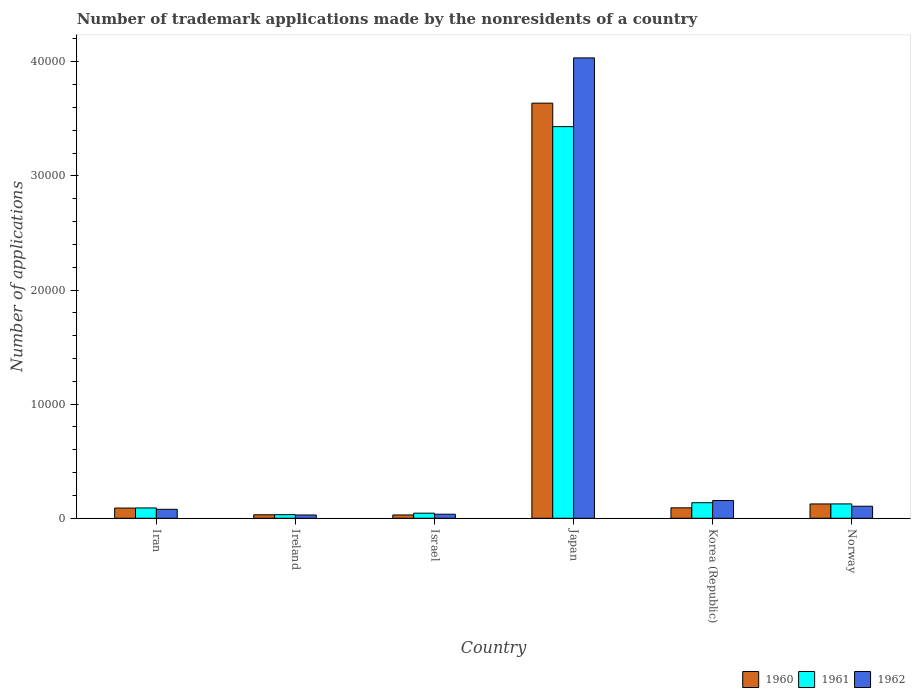How many different coloured bars are there?
Make the answer very short. 3. How many groups of bars are there?
Your answer should be compact. 6. How many bars are there on the 5th tick from the left?
Your answer should be compact. 3. What is the label of the 5th group of bars from the left?
Provide a short and direct response. Korea (Republic). In how many cases, is the number of bars for a given country not equal to the number of legend labels?
Provide a succinct answer. 0. What is the number of trademark applications made by the nonresidents in 1960 in Korea (Republic)?
Offer a very short reply. 916. Across all countries, what is the maximum number of trademark applications made by the nonresidents in 1961?
Ensure brevity in your answer.  3.43e+04. Across all countries, what is the minimum number of trademark applications made by the nonresidents in 1962?
Provide a succinct answer. 288. In which country was the number of trademark applications made by the nonresidents in 1962 minimum?
Keep it short and to the point. Ireland. What is the total number of trademark applications made by the nonresidents in 1962 in the graph?
Offer a very short reply. 4.44e+04. What is the difference between the number of trademark applications made by the nonresidents in 1962 in Japan and that in Norway?
Ensure brevity in your answer.  3.93e+04. What is the difference between the number of trademark applications made by the nonresidents in 1961 in Ireland and the number of trademark applications made by the nonresidents in 1962 in Japan?
Offer a very short reply. -4.00e+04. What is the average number of trademark applications made by the nonresidents in 1962 per country?
Keep it short and to the point. 7396.83. What is the difference between the number of trademark applications made by the nonresidents of/in 1962 and number of trademark applications made by the nonresidents of/in 1961 in Norway?
Your answer should be compact. -203. In how many countries, is the number of trademark applications made by the nonresidents in 1961 greater than 30000?
Offer a very short reply. 1. What is the ratio of the number of trademark applications made by the nonresidents in 1961 in Israel to that in Norway?
Make the answer very short. 0.35. Is the number of trademark applications made by the nonresidents in 1962 in Ireland less than that in Japan?
Your answer should be very brief. Yes. What is the difference between the highest and the second highest number of trademark applications made by the nonresidents in 1962?
Make the answer very short. 499. What is the difference between the highest and the lowest number of trademark applications made by the nonresidents in 1960?
Your answer should be very brief. 3.61e+04. Is the sum of the number of trademark applications made by the nonresidents in 1960 in Japan and Norway greater than the maximum number of trademark applications made by the nonresidents in 1961 across all countries?
Your answer should be compact. Yes. What does the 2nd bar from the right in Israel represents?
Give a very brief answer. 1961. How many bars are there?
Your answer should be very brief. 18. Are all the bars in the graph horizontal?
Offer a terse response. No. How many countries are there in the graph?
Provide a succinct answer. 6. What is the difference between two consecutive major ticks on the Y-axis?
Your answer should be compact. 10000. Are the values on the major ticks of Y-axis written in scientific E-notation?
Offer a terse response. No. Does the graph contain grids?
Offer a very short reply. No. How are the legend labels stacked?
Ensure brevity in your answer.  Horizontal. What is the title of the graph?
Your answer should be compact. Number of trademark applications made by the nonresidents of a country. Does "2009" appear as one of the legend labels in the graph?
Offer a very short reply. No. What is the label or title of the X-axis?
Offer a very short reply. Country. What is the label or title of the Y-axis?
Provide a short and direct response. Number of applications. What is the Number of applications of 1960 in Iran?
Make the answer very short. 895. What is the Number of applications of 1961 in Iran?
Your answer should be compact. 905. What is the Number of applications in 1962 in Iran?
Your answer should be very brief. 786. What is the Number of applications of 1960 in Ireland?
Give a very brief answer. 305. What is the Number of applications in 1961 in Ireland?
Offer a very short reply. 316. What is the Number of applications of 1962 in Ireland?
Your response must be concise. 288. What is the Number of applications of 1960 in Israel?
Ensure brevity in your answer.  290. What is the Number of applications of 1961 in Israel?
Ensure brevity in your answer.  446. What is the Number of applications of 1962 in Israel?
Make the answer very short. 355. What is the Number of applications of 1960 in Japan?
Offer a very short reply. 3.64e+04. What is the Number of applications in 1961 in Japan?
Your response must be concise. 3.43e+04. What is the Number of applications of 1962 in Japan?
Keep it short and to the point. 4.03e+04. What is the Number of applications of 1960 in Korea (Republic)?
Your answer should be compact. 916. What is the Number of applications of 1961 in Korea (Republic)?
Offer a very short reply. 1363. What is the Number of applications in 1962 in Korea (Republic)?
Offer a terse response. 1554. What is the Number of applications of 1960 in Norway?
Offer a very short reply. 1255. What is the Number of applications of 1961 in Norway?
Offer a terse response. 1258. What is the Number of applications in 1962 in Norway?
Your answer should be compact. 1055. Across all countries, what is the maximum Number of applications of 1960?
Your answer should be very brief. 3.64e+04. Across all countries, what is the maximum Number of applications of 1961?
Offer a terse response. 3.43e+04. Across all countries, what is the maximum Number of applications of 1962?
Provide a succinct answer. 4.03e+04. Across all countries, what is the minimum Number of applications in 1960?
Offer a terse response. 290. Across all countries, what is the minimum Number of applications in 1961?
Keep it short and to the point. 316. Across all countries, what is the minimum Number of applications of 1962?
Provide a short and direct response. 288. What is the total Number of applications in 1960 in the graph?
Provide a succinct answer. 4.00e+04. What is the total Number of applications in 1961 in the graph?
Your answer should be compact. 3.86e+04. What is the total Number of applications of 1962 in the graph?
Ensure brevity in your answer.  4.44e+04. What is the difference between the Number of applications of 1960 in Iran and that in Ireland?
Offer a very short reply. 590. What is the difference between the Number of applications of 1961 in Iran and that in Ireland?
Give a very brief answer. 589. What is the difference between the Number of applications in 1962 in Iran and that in Ireland?
Make the answer very short. 498. What is the difference between the Number of applications of 1960 in Iran and that in Israel?
Ensure brevity in your answer.  605. What is the difference between the Number of applications of 1961 in Iran and that in Israel?
Provide a succinct answer. 459. What is the difference between the Number of applications in 1962 in Iran and that in Israel?
Your response must be concise. 431. What is the difference between the Number of applications in 1960 in Iran and that in Japan?
Offer a very short reply. -3.55e+04. What is the difference between the Number of applications of 1961 in Iran and that in Japan?
Offer a very short reply. -3.34e+04. What is the difference between the Number of applications in 1962 in Iran and that in Japan?
Your answer should be compact. -3.96e+04. What is the difference between the Number of applications in 1960 in Iran and that in Korea (Republic)?
Your response must be concise. -21. What is the difference between the Number of applications of 1961 in Iran and that in Korea (Republic)?
Provide a short and direct response. -458. What is the difference between the Number of applications in 1962 in Iran and that in Korea (Republic)?
Provide a succinct answer. -768. What is the difference between the Number of applications in 1960 in Iran and that in Norway?
Provide a succinct answer. -360. What is the difference between the Number of applications in 1961 in Iran and that in Norway?
Your answer should be compact. -353. What is the difference between the Number of applications of 1962 in Iran and that in Norway?
Your answer should be very brief. -269. What is the difference between the Number of applications of 1960 in Ireland and that in Israel?
Keep it short and to the point. 15. What is the difference between the Number of applications of 1961 in Ireland and that in Israel?
Your response must be concise. -130. What is the difference between the Number of applications in 1962 in Ireland and that in Israel?
Offer a terse response. -67. What is the difference between the Number of applications in 1960 in Ireland and that in Japan?
Give a very brief answer. -3.61e+04. What is the difference between the Number of applications in 1961 in Ireland and that in Japan?
Your answer should be very brief. -3.40e+04. What is the difference between the Number of applications of 1962 in Ireland and that in Japan?
Offer a very short reply. -4.01e+04. What is the difference between the Number of applications in 1960 in Ireland and that in Korea (Republic)?
Your answer should be very brief. -611. What is the difference between the Number of applications in 1961 in Ireland and that in Korea (Republic)?
Offer a very short reply. -1047. What is the difference between the Number of applications of 1962 in Ireland and that in Korea (Republic)?
Make the answer very short. -1266. What is the difference between the Number of applications in 1960 in Ireland and that in Norway?
Your answer should be very brief. -950. What is the difference between the Number of applications of 1961 in Ireland and that in Norway?
Keep it short and to the point. -942. What is the difference between the Number of applications in 1962 in Ireland and that in Norway?
Your response must be concise. -767. What is the difference between the Number of applications in 1960 in Israel and that in Japan?
Your answer should be compact. -3.61e+04. What is the difference between the Number of applications in 1961 in Israel and that in Japan?
Give a very brief answer. -3.39e+04. What is the difference between the Number of applications in 1962 in Israel and that in Japan?
Keep it short and to the point. -4.00e+04. What is the difference between the Number of applications of 1960 in Israel and that in Korea (Republic)?
Keep it short and to the point. -626. What is the difference between the Number of applications of 1961 in Israel and that in Korea (Republic)?
Your answer should be compact. -917. What is the difference between the Number of applications of 1962 in Israel and that in Korea (Republic)?
Your answer should be compact. -1199. What is the difference between the Number of applications of 1960 in Israel and that in Norway?
Give a very brief answer. -965. What is the difference between the Number of applications of 1961 in Israel and that in Norway?
Make the answer very short. -812. What is the difference between the Number of applications in 1962 in Israel and that in Norway?
Make the answer very short. -700. What is the difference between the Number of applications in 1960 in Japan and that in Korea (Republic)?
Give a very brief answer. 3.55e+04. What is the difference between the Number of applications in 1961 in Japan and that in Korea (Republic)?
Provide a short and direct response. 3.30e+04. What is the difference between the Number of applications of 1962 in Japan and that in Korea (Republic)?
Offer a very short reply. 3.88e+04. What is the difference between the Number of applications of 1960 in Japan and that in Norway?
Provide a succinct answer. 3.51e+04. What is the difference between the Number of applications of 1961 in Japan and that in Norway?
Provide a succinct answer. 3.31e+04. What is the difference between the Number of applications of 1962 in Japan and that in Norway?
Give a very brief answer. 3.93e+04. What is the difference between the Number of applications in 1960 in Korea (Republic) and that in Norway?
Your answer should be very brief. -339. What is the difference between the Number of applications of 1961 in Korea (Republic) and that in Norway?
Make the answer very short. 105. What is the difference between the Number of applications of 1962 in Korea (Republic) and that in Norway?
Ensure brevity in your answer.  499. What is the difference between the Number of applications in 1960 in Iran and the Number of applications in 1961 in Ireland?
Provide a succinct answer. 579. What is the difference between the Number of applications of 1960 in Iran and the Number of applications of 1962 in Ireland?
Your response must be concise. 607. What is the difference between the Number of applications in 1961 in Iran and the Number of applications in 1962 in Ireland?
Give a very brief answer. 617. What is the difference between the Number of applications of 1960 in Iran and the Number of applications of 1961 in Israel?
Make the answer very short. 449. What is the difference between the Number of applications of 1960 in Iran and the Number of applications of 1962 in Israel?
Ensure brevity in your answer.  540. What is the difference between the Number of applications in 1961 in Iran and the Number of applications in 1962 in Israel?
Your answer should be very brief. 550. What is the difference between the Number of applications in 1960 in Iran and the Number of applications in 1961 in Japan?
Offer a terse response. -3.34e+04. What is the difference between the Number of applications in 1960 in Iran and the Number of applications in 1962 in Japan?
Your response must be concise. -3.94e+04. What is the difference between the Number of applications of 1961 in Iran and the Number of applications of 1962 in Japan?
Ensure brevity in your answer.  -3.94e+04. What is the difference between the Number of applications of 1960 in Iran and the Number of applications of 1961 in Korea (Republic)?
Make the answer very short. -468. What is the difference between the Number of applications of 1960 in Iran and the Number of applications of 1962 in Korea (Republic)?
Your answer should be very brief. -659. What is the difference between the Number of applications in 1961 in Iran and the Number of applications in 1962 in Korea (Republic)?
Ensure brevity in your answer.  -649. What is the difference between the Number of applications of 1960 in Iran and the Number of applications of 1961 in Norway?
Your response must be concise. -363. What is the difference between the Number of applications of 1960 in Iran and the Number of applications of 1962 in Norway?
Your answer should be very brief. -160. What is the difference between the Number of applications in 1961 in Iran and the Number of applications in 1962 in Norway?
Offer a very short reply. -150. What is the difference between the Number of applications in 1960 in Ireland and the Number of applications in 1961 in Israel?
Ensure brevity in your answer.  -141. What is the difference between the Number of applications of 1960 in Ireland and the Number of applications of 1962 in Israel?
Make the answer very short. -50. What is the difference between the Number of applications of 1961 in Ireland and the Number of applications of 1962 in Israel?
Your response must be concise. -39. What is the difference between the Number of applications in 1960 in Ireland and the Number of applications in 1961 in Japan?
Your answer should be compact. -3.40e+04. What is the difference between the Number of applications of 1960 in Ireland and the Number of applications of 1962 in Japan?
Your answer should be compact. -4.00e+04. What is the difference between the Number of applications of 1961 in Ireland and the Number of applications of 1962 in Japan?
Your answer should be compact. -4.00e+04. What is the difference between the Number of applications of 1960 in Ireland and the Number of applications of 1961 in Korea (Republic)?
Provide a succinct answer. -1058. What is the difference between the Number of applications in 1960 in Ireland and the Number of applications in 1962 in Korea (Republic)?
Your response must be concise. -1249. What is the difference between the Number of applications in 1961 in Ireland and the Number of applications in 1962 in Korea (Republic)?
Make the answer very short. -1238. What is the difference between the Number of applications in 1960 in Ireland and the Number of applications in 1961 in Norway?
Provide a short and direct response. -953. What is the difference between the Number of applications of 1960 in Ireland and the Number of applications of 1962 in Norway?
Make the answer very short. -750. What is the difference between the Number of applications in 1961 in Ireland and the Number of applications in 1962 in Norway?
Keep it short and to the point. -739. What is the difference between the Number of applications of 1960 in Israel and the Number of applications of 1961 in Japan?
Your answer should be very brief. -3.40e+04. What is the difference between the Number of applications in 1960 in Israel and the Number of applications in 1962 in Japan?
Keep it short and to the point. -4.01e+04. What is the difference between the Number of applications of 1961 in Israel and the Number of applications of 1962 in Japan?
Offer a very short reply. -3.99e+04. What is the difference between the Number of applications of 1960 in Israel and the Number of applications of 1961 in Korea (Republic)?
Make the answer very short. -1073. What is the difference between the Number of applications in 1960 in Israel and the Number of applications in 1962 in Korea (Republic)?
Keep it short and to the point. -1264. What is the difference between the Number of applications in 1961 in Israel and the Number of applications in 1962 in Korea (Republic)?
Your answer should be very brief. -1108. What is the difference between the Number of applications in 1960 in Israel and the Number of applications in 1961 in Norway?
Ensure brevity in your answer.  -968. What is the difference between the Number of applications in 1960 in Israel and the Number of applications in 1962 in Norway?
Your answer should be very brief. -765. What is the difference between the Number of applications in 1961 in Israel and the Number of applications in 1962 in Norway?
Keep it short and to the point. -609. What is the difference between the Number of applications of 1960 in Japan and the Number of applications of 1961 in Korea (Republic)?
Provide a succinct answer. 3.50e+04. What is the difference between the Number of applications of 1960 in Japan and the Number of applications of 1962 in Korea (Republic)?
Provide a short and direct response. 3.48e+04. What is the difference between the Number of applications in 1961 in Japan and the Number of applications in 1962 in Korea (Republic)?
Provide a short and direct response. 3.28e+04. What is the difference between the Number of applications of 1960 in Japan and the Number of applications of 1961 in Norway?
Make the answer very short. 3.51e+04. What is the difference between the Number of applications of 1960 in Japan and the Number of applications of 1962 in Norway?
Make the answer very short. 3.53e+04. What is the difference between the Number of applications of 1961 in Japan and the Number of applications of 1962 in Norway?
Keep it short and to the point. 3.33e+04. What is the difference between the Number of applications of 1960 in Korea (Republic) and the Number of applications of 1961 in Norway?
Offer a terse response. -342. What is the difference between the Number of applications in 1960 in Korea (Republic) and the Number of applications in 1962 in Norway?
Offer a very short reply. -139. What is the difference between the Number of applications of 1961 in Korea (Republic) and the Number of applications of 1962 in Norway?
Give a very brief answer. 308. What is the average Number of applications in 1960 per country?
Give a very brief answer. 6673. What is the average Number of applications of 1961 per country?
Offer a very short reply. 6434.67. What is the average Number of applications of 1962 per country?
Provide a short and direct response. 7396.83. What is the difference between the Number of applications of 1960 and Number of applications of 1961 in Iran?
Your answer should be very brief. -10. What is the difference between the Number of applications in 1960 and Number of applications in 1962 in Iran?
Keep it short and to the point. 109. What is the difference between the Number of applications of 1961 and Number of applications of 1962 in Iran?
Your answer should be compact. 119. What is the difference between the Number of applications of 1960 and Number of applications of 1961 in Ireland?
Your response must be concise. -11. What is the difference between the Number of applications in 1960 and Number of applications in 1962 in Ireland?
Ensure brevity in your answer.  17. What is the difference between the Number of applications of 1961 and Number of applications of 1962 in Ireland?
Your answer should be very brief. 28. What is the difference between the Number of applications of 1960 and Number of applications of 1961 in Israel?
Provide a short and direct response. -156. What is the difference between the Number of applications of 1960 and Number of applications of 1962 in Israel?
Make the answer very short. -65. What is the difference between the Number of applications of 1961 and Number of applications of 1962 in Israel?
Give a very brief answer. 91. What is the difference between the Number of applications of 1960 and Number of applications of 1961 in Japan?
Ensure brevity in your answer.  2057. What is the difference between the Number of applications of 1960 and Number of applications of 1962 in Japan?
Ensure brevity in your answer.  -3966. What is the difference between the Number of applications of 1961 and Number of applications of 1962 in Japan?
Ensure brevity in your answer.  -6023. What is the difference between the Number of applications of 1960 and Number of applications of 1961 in Korea (Republic)?
Provide a short and direct response. -447. What is the difference between the Number of applications of 1960 and Number of applications of 1962 in Korea (Republic)?
Give a very brief answer. -638. What is the difference between the Number of applications of 1961 and Number of applications of 1962 in Korea (Republic)?
Your answer should be very brief. -191. What is the difference between the Number of applications in 1960 and Number of applications in 1961 in Norway?
Your response must be concise. -3. What is the difference between the Number of applications of 1961 and Number of applications of 1962 in Norway?
Your answer should be very brief. 203. What is the ratio of the Number of applications of 1960 in Iran to that in Ireland?
Make the answer very short. 2.93. What is the ratio of the Number of applications of 1961 in Iran to that in Ireland?
Keep it short and to the point. 2.86. What is the ratio of the Number of applications in 1962 in Iran to that in Ireland?
Give a very brief answer. 2.73. What is the ratio of the Number of applications of 1960 in Iran to that in Israel?
Your answer should be compact. 3.09. What is the ratio of the Number of applications of 1961 in Iran to that in Israel?
Offer a very short reply. 2.03. What is the ratio of the Number of applications of 1962 in Iran to that in Israel?
Offer a terse response. 2.21. What is the ratio of the Number of applications of 1960 in Iran to that in Japan?
Ensure brevity in your answer.  0.02. What is the ratio of the Number of applications of 1961 in Iran to that in Japan?
Your answer should be compact. 0.03. What is the ratio of the Number of applications of 1962 in Iran to that in Japan?
Provide a succinct answer. 0.02. What is the ratio of the Number of applications of 1960 in Iran to that in Korea (Republic)?
Your answer should be very brief. 0.98. What is the ratio of the Number of applications of 1961 in Iran to that in Korea (Republic)?
Provide a succinct answer. 0.66. What is the ratio of the Number of applications of 1962 in Iran to that in Korea (Republic)?
Your response must be concise. 0.51. What is the ratio of the Number of applications in 1960 in Iran to that in Norway?
Your answer should be compact. 0.71. What is the ratio of the Number of applications of 1961 in Iran to that in Norway?
Make the answer very short. 0.72. What is the ratio of the Number of applications in 1962 in Iran to that in Norway?
Offer a very short reply. 0.74. What is the ratio of the Number of applications in 1960 in Ireland to that in Israel?
Your answer should be very brief. 1.05. What is the ratio of the Number of applications in 1961 in Ireland to that in Israel?
Offer a very short reply. 0.71. What is the ratio of the Number of applications of 1962 in Ireland to that in Israel?
Your answer should be compact. 0.81. What is the ratio of the Number of applications of 1960 in Ireland to that in Japan?
Offer a terse response. 0.01. What is the ratio of the Number of applications of 1961 in Ireland to that in Japan?
Keep it short and to the point. 0.01. What is the ratio of the Number of applications of 1962 in Ireland to that in Japan?
Provide a short and direct response. 0.01. What is the ratio of the Number of applications in 1960 in Ireland to that in Korea (Republic)?
Offer a terse response. 0.33. What is the ratio of the Number of applications of 1961 in Ireland to that in Korea (Republic)?
Your answer should be compact. 0.23. What is the ratio of the Number of applications of 1962 in Ireland to that in Korea (Republic)?
Give a very brief answer. 0.19. What is the ratio of the Number of applications in 1960 in Ireland to that in Norway?
Your answer should be very brief. 0.24. What is the ratio of the Number of applications in 1961 in Ireland to that in Norway?
Provide a short and direct response. 0.25. What is the ratio of the Number of applications in 1962 in Ireland to that in Norway?
Provide a short and direct response. 0.27. What is the ratio of the Number of applications of 1960 in Israel to that in Japan?
Offer a very short reply. 0.01. What is the ratio of the Number of applications in 1961 in Israel to that in Japan?
Your response must be concise. 0.01. What is the ratio of the Number of applications of 1962 in Israel to that in Japan?
Offer a terse response. 0.01. What is the ratio of the Number of applications of 1960 in Israel to that in Korea (Republic)?
Your answer should be very brief. 0.32. What is the ratio of the Number of applications in 1961 in Israel to that in Korea (Republic)?
Offer a very short reply. 0.33. What is the ratio of the Number of applications in 1962 in Israel to that in Korea (Republic)?
Your answer should be compact. 0.23. What is the ratio of the Number of applications in 1960 in Israel to that in Norway?
Keep it short and to the point. 0.23. What is the ratio of the Number of applications of 1961 in Israel to that in Norway?
Your response must be concise. 0.35. What is the ratio of the Number of applications in 1962 in Israel to that in Norway?
Your answer should be very brief. 0.34. What is the ratio of the Number of applications in 1960 in Japan to that in Korea (Republic)?
Offer a very short reply. 39.71. What is the ratio of the Number of applications of 1961 in Japan to that in Korea (Republic)?
Give a very brief answer. 25.18. What is the ratio of the Number of applications in 1962 in Japan to that in Korea (Republic)?
Provide a short and direct response. 25.96. What is the ratio of the Number of applications in 1960 in Japan to that in Norway?
Your response must be concise. 28.99. What is the ratio of the Number of applications of 1961 in Japan to that in Norway?
Make the answer very short. 27.28. What is the ratio of the Number of applications in 1962 in Japan to that in Norway?
Provide a short and direct response. 38.24. What is the ratio of the Number of applications in 1960 in Korea (Republic) to that in Norway?
Your answer should be very brief. 0.73. What is the ratio of the Number of applications of 1961 in Korea (Republic) to that in Norway?
Provide a short and direct response. 1.08. What is the ratio of the Number of applications of 1962 in Korea (Republic) to that in Norway?
Offer a terse response. 1.47. What is the difference between the highest and the second highest Number of applications of 1960?
Your answer should be compact. 3.51e+04. What is the difference between the highest and the second highest Number of applications in 1961?
Make the answer very short. 3.30e+04. What is the difference between the highest and the second highest Number of applications of 1962?
Offer a very short reply. 3.88e+04. What is the difference between the highest and the lowest Number of applications of 1960?
Your answer should be very brief. 3.61e+04. What is the difference between the highest and the lowest Number of applications of 1961?
Offer a terse response. 3.40e+04. What is the difference between the highest and the lowest Number of applications of 1962?
Provide a short and direct response. 4.01e+04. 